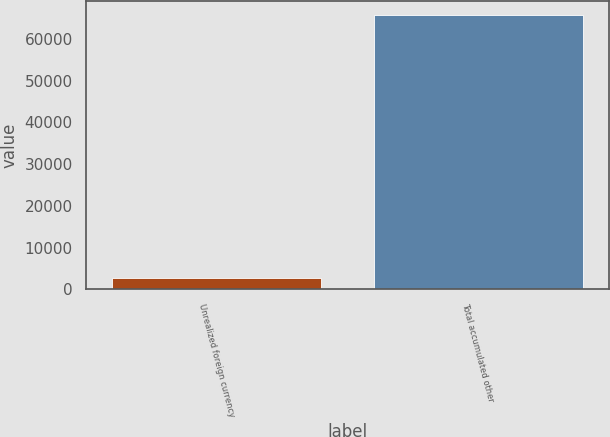Convert chart. <chart><loc_0><loc_0><loc_500><loc_500><bar_chart><fcel>Unrealized foreign currency<fcel>Total accumulated other<nl><fcel>2717<fcel>65741<nl></chart> 